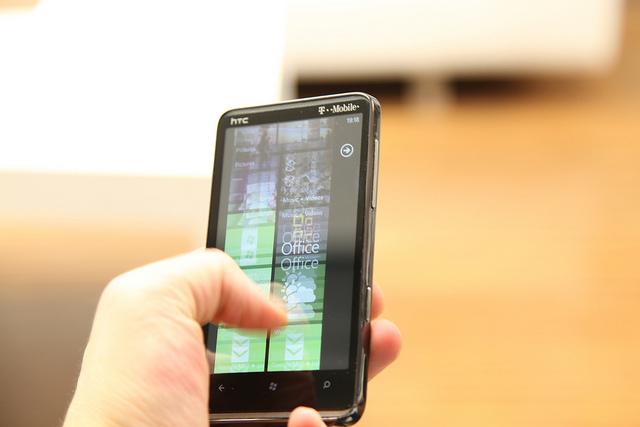What brand of phone is it?
Short answer required. Htc. What color is the phone's case?
Answer briefly. Black. What sort of phone is this?
Be succinct. Htc. Is this a flip phone?
Give a very brief answer. No. 